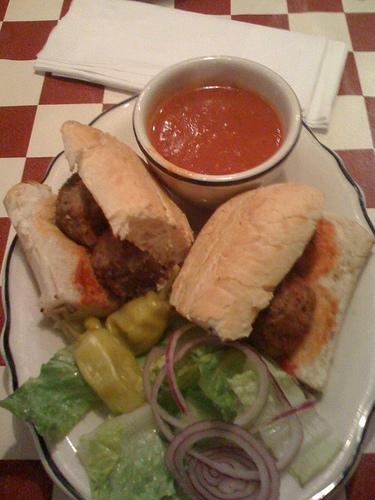Question: where is the sandwich?
Choices:
A. In the hands.
B. In the bag.
C. On the plate.
D. In the basket.
Answer with the letter. Answer: C Question: how many peppers are pictured?
Choices:
A. 12.
B. 2.
C. 13.
D. 5.
Answer with the letter. Answer: B Question: what pattern is on the table?
Choices:
A. Checkered.
B. Striped.
C. Polka dots.
D. Gingham.
Answer with the letter. Answer: A Question: what color is the tabletop?
Choices:
A. Teal.
B. Purple.
C. Red and white.
D. Neon.
Answer with the letter. Answer: C Question: how has the sandwich been cut?
Choices:
A. In half.
B. In fourths.
C. It wasn't cut at all.
D. In eighths.
Answer with the letter. Answer: A Question: what sandwich is pictured?
Choices:
A. Ham.
B. Roast beef.
C. Grilled cheese.
D. Meatball.
Answer with the letter. Answer: D Question: what color is the sauce in the bowl?
Choices:
A. Teal.
B. Purple.
C. Red.
D. Neon.
Answer with the letter. Answer: C 